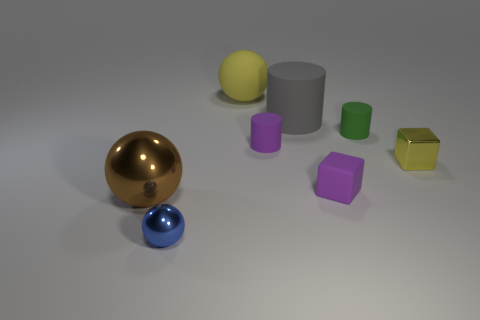There is a rubber block; does it have the same color as the rubber cylinder that is in front of the green matte cylinder?
Ensure brevity in your answer.  Yes. The rubber thing that is the same color as the metal cube is what shape?
Your answer should be very brief. Sphere. How many big things are spheres or blue metal cubes?
Keep it short and to the point. 2. There is a rubber cylinder that is the same color as the tiny rubber block; what size is it?
Keep it short and to the point. Small. What is the color of the ball that is right of the shiny sphere that is in front of the brown sphere?
Ensure brevity in your answer.  Yellow. Are the green cylinder and the sphere that is on the right side of the small shiny ball made of the same material?
Your answer should be compact. Yes. There is a big object that is right of the matte sphere; what is it made of?
Give a very brief answer. Rubber. Are there the same number of tiny yellow blocks left of the large brown sphere and shiny balls?
Your answer should be compact. No. What material is the object in front of the shiny ball to the left of the blue sphere made of?
Your answer should be compact. Metal. There is a small thing that is both left of the purple cube and in front of the tiny yellow thing; what is its shape?
Offer a terse response. Sphere. 